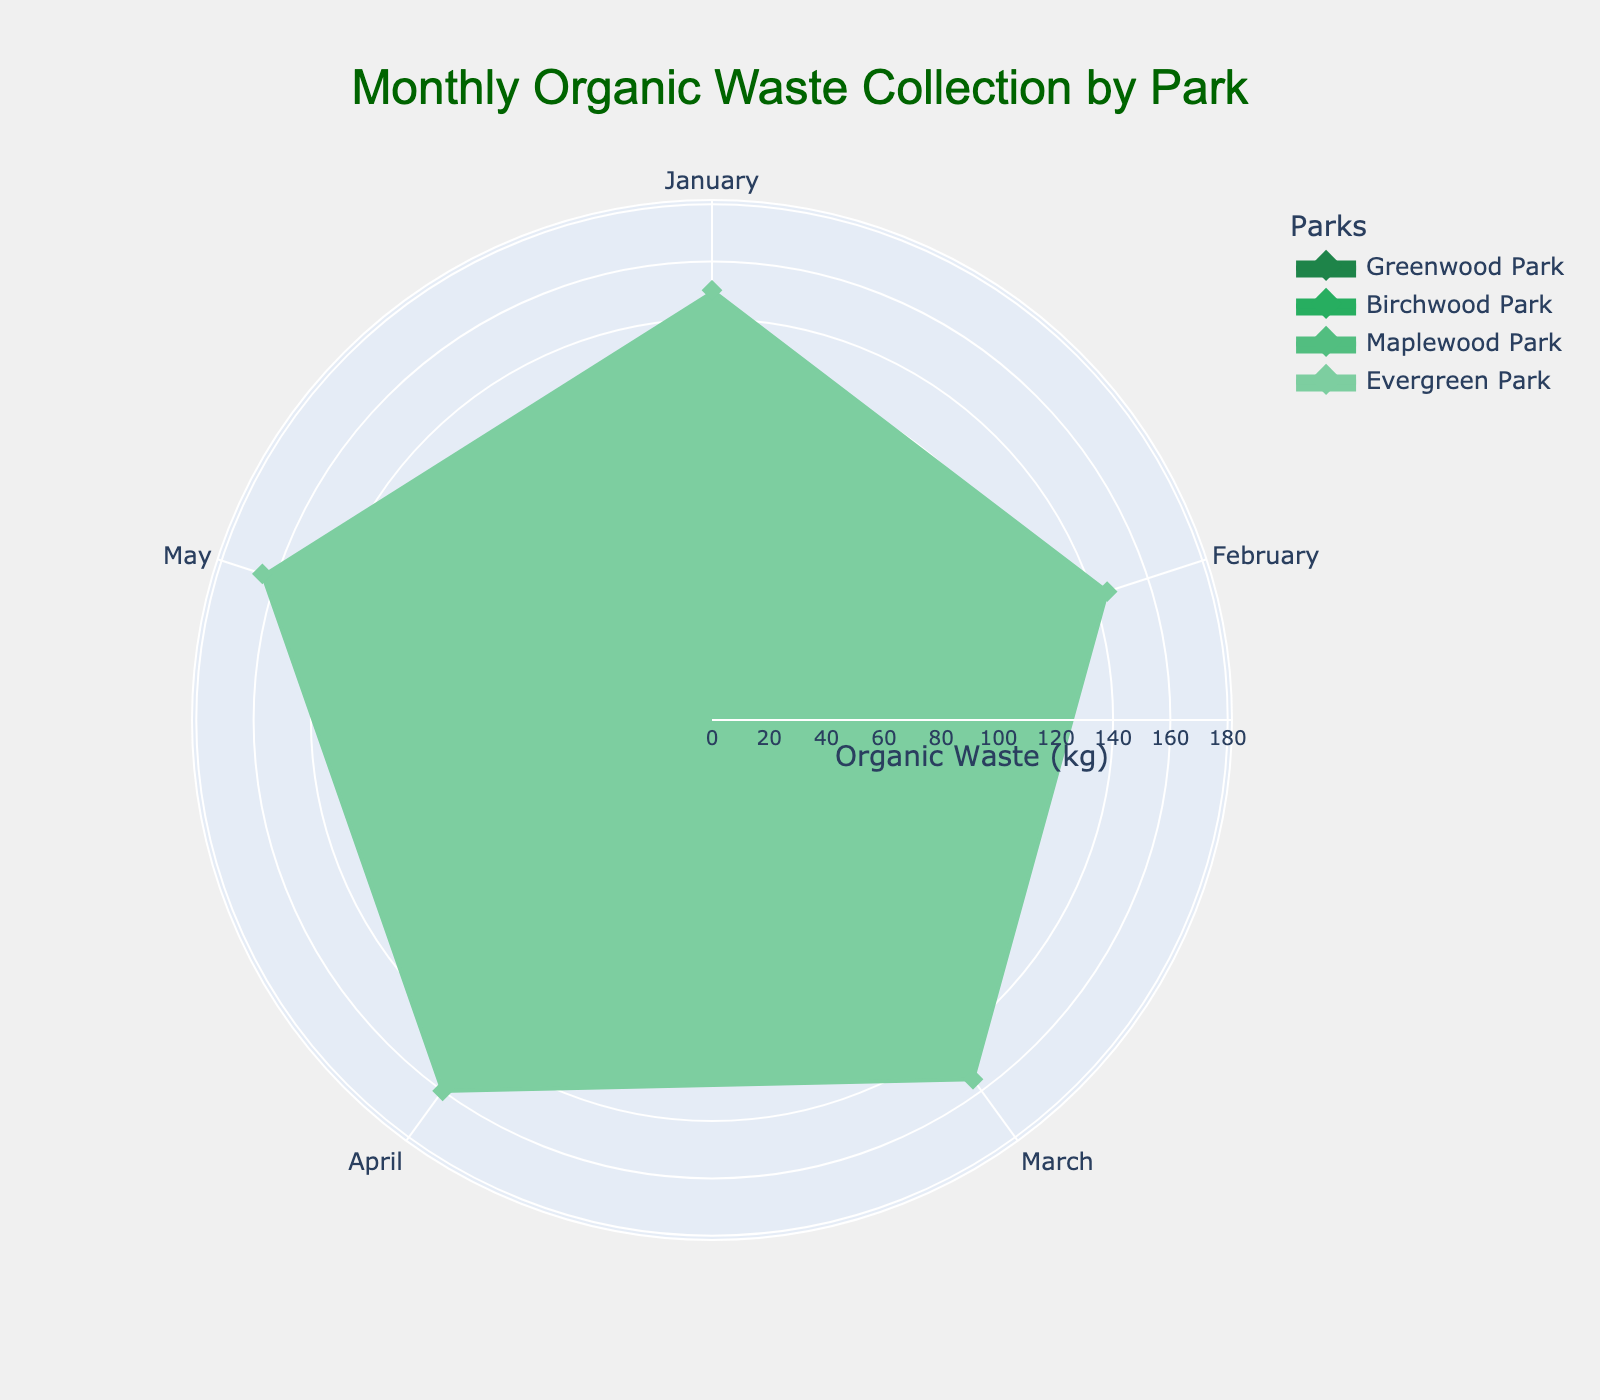What is the title of the chart? The title is usually displayed at the top of the chart. In this case, the title reads "Monthly Organic Waste Collection by Park."
Answer: Monthly Organic Waste Collection by Park Which month has the highest organic waste collection in Evergreen Park? For Evergreen Park, the line furthest from the center, indicating the highest value, is observed in May.
Answer: May What color is used to represent Greenwood Park? The marker color for Greenwood Park can be identified by observing the color of its data points or lines. It is colored in varying shades of green starting with the darkest.
Answer: Dark green How many parks are included in the chart? Each park is represented by a different line and fill on the chart. Counting these distinct lines gives the total number of parks, which is four.
Answer: Four What is the range of the radial axis? The radial axis shows the range from the lowest to highest values. Here, it ranges from 0 to the maximum value found in the dataset multiplied by 1.1. Therefore, it spans from 0 to 181.5 kg.
Answer: 0 to 181.5 kg How does the organic waste collection in Birchwood Park compare from January to May? To compare, observe the shape and size of the filled area. The organic waste collection in Birchwood Park increases sequentially from January (100 kg) to May (125 kg).
Answer: It increases Which park collected the least amount of organic waste in February? Looking at the data points for February, Maplewood Park has the smallest radius, indicating it has the least amount, which is 78 kg.
Answer: Maplewood Park What is the difference between the maximum and minimum organic waste collection in Greenwood Park? For Greenwood Park, the maximum collection is in May (150 kg) and the minimum is in February (110 kg). The difference is 150 - 110 = 40 kg.
Answer: 40 kg Which park has the most consistent organic waste collection across all months? Consistency can be identified by a similar distance from the center across all months. Evergreen Park shows relatively even distances for each month, indicating consistency.
Answer: Evergreen Park 